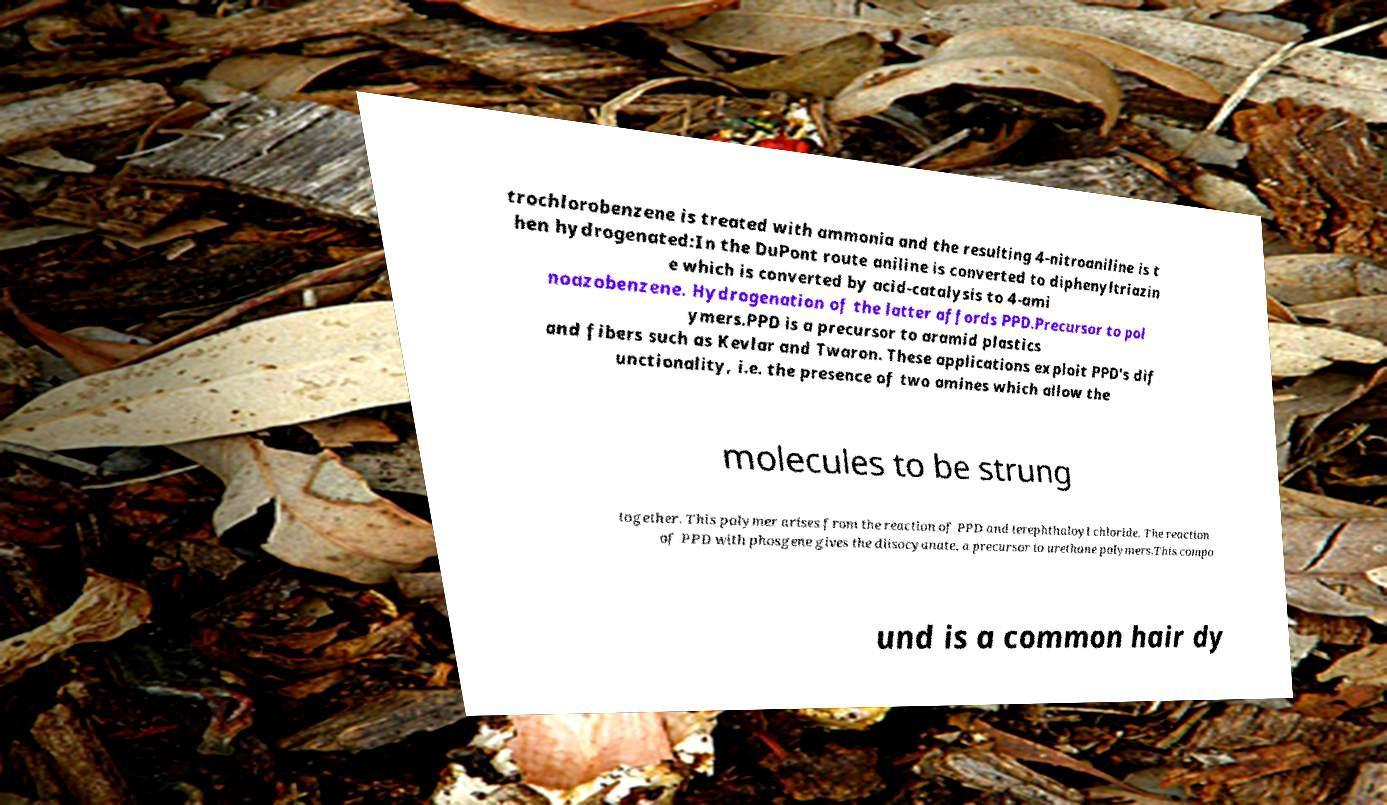There's text embedded in this image that I need extracted. Can you transcribe it verbatim? trochlorobenzene is treated with ammonia and the resulting 4-nitroaniline is t hen hydrogenated:In the DuPont route aniline is converted to diphenyltriazin e which is converted by acid-catalysis to 4-ami noazobenzene. Hydrogenation of the latter affords PPD.Precursor to pol ymers.PPD is a precursor to aramid plastics and fibers such as Kevlar and Twaron. These applications exploit PPD's dif unctionality, i.e. the presence of two amines which allow the molecules to be strung together. This polymer arises from the reaction of PPD and terephthaloyl chloride. The reaction of PPD with phosgene gives the diisocyanate, a precursor to urethane polymers.This compo und is a common hair dy 